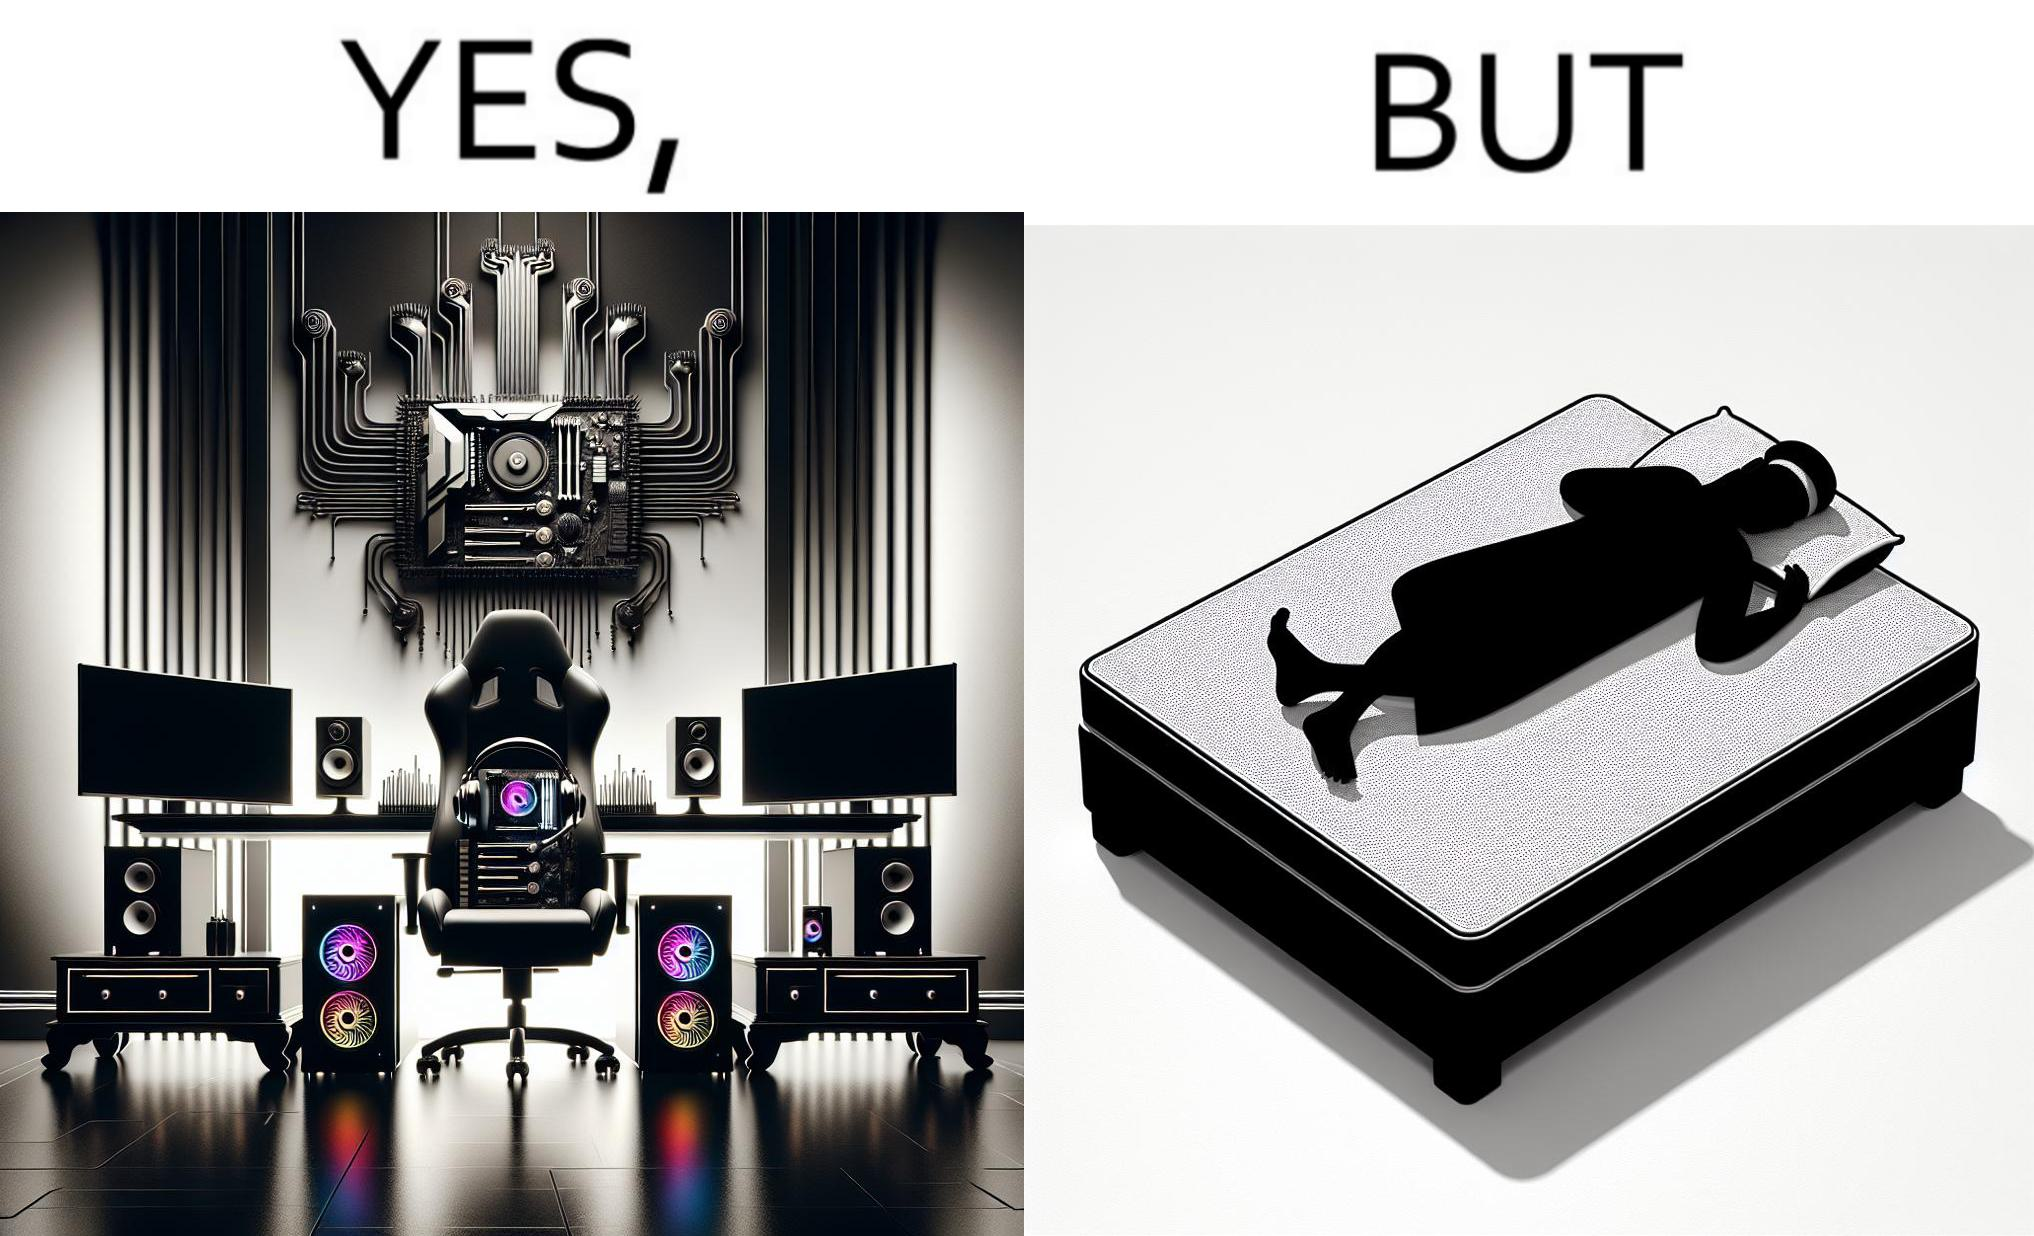What makes this image funny or satirical? The image is funny because the person has a lot of furniture for his computer but none for himself. 